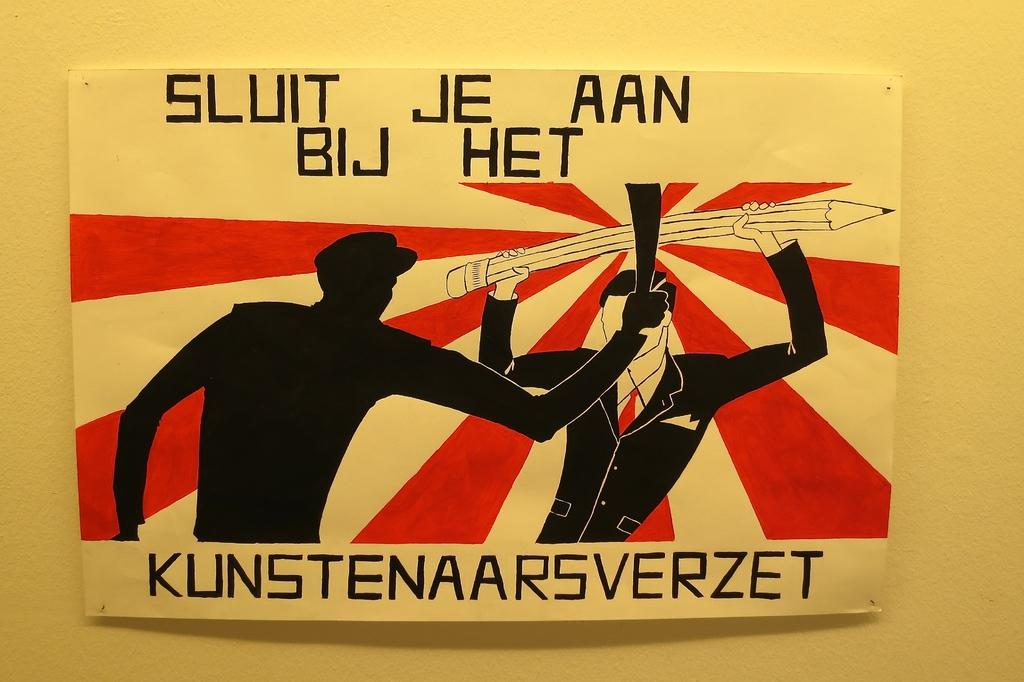<image>
Describe the image concisely. A hand drawn poster says "sluit je aan bij het" at the top. 